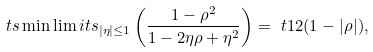Convert formula to latex. <formula><loc_0><loc_0><loc_500><loc_500>\ t s \min \lim i t s _ { | \eta | \leq 1 } \left ( \frac { 1 - \rho ^ { 2 } } { 1 - 2 \eta \rho + \eta ^ { 2 } } \right ) = \ t 1 2 ( 1 - | \rho | ) ,</formula> 